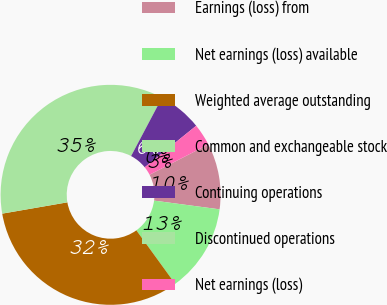Convert chart. <chart><loc_0><loc_0><loc_500><loc_500><pie_chart><fcel>Earnings (loss) from<fcel>Net earnings (loss) available<fcel>Weighted average outstanding<fcel>Common and exchangeable stock<fcel>Continuing operations<fcel>Discontinued operations<fcel>Net earnings (loss)<nl><fcel>9.68%<fcel>12.9%<fcel>32.26%<fcel>35.48%<fcel>6.45%<fcel>0.0%<fcel>3.23%<nl></chart> 